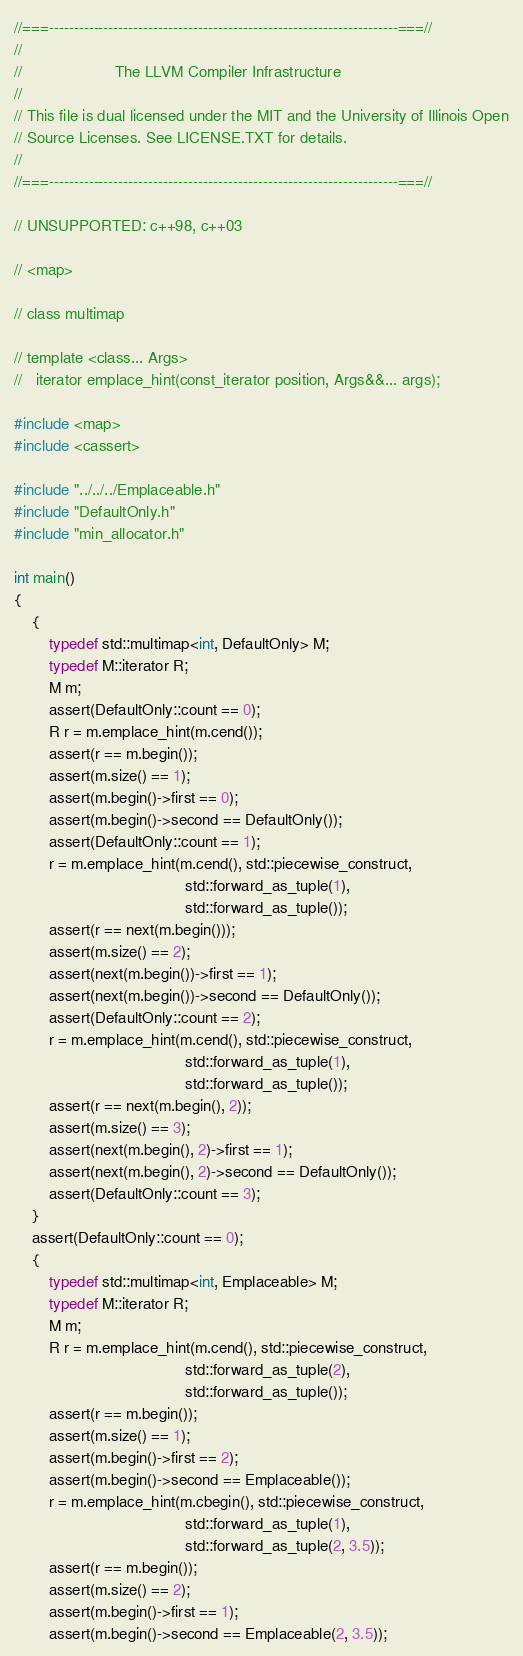Convert code to text. <code><loc_0><loc_0><loc_500><loc_500><_C++_>//===----------------------------------------------------------------------===//
//
//                     The LLVM Compiler Infrastructure
//
// This file is dual licensed under the MIT and the University of Illinois Open
// Source Licenses. See LICENSE.TXT for details.
//
//===----------------------------------------------------------------------===//

// UNSUPPORTED: c++98, c++03

// <map>

// class multimap

// template <class... Args>
//   iterator emplace_hint(const_iterator position, Args&&... args);

#include <map>
#include <cassert>

#include "../../../Emplaceable.h"
#include "DefaultOnly.h"
#include "min_allocator.h"

int main()
{
    {
        typedef std::multimap<int, DefaultOnly> M;
        typedef M::iterator R;
        M m;
        assert(DefaultOnly::count == 0);
        R r = m.emplace_hint(m.cend());
        assert(r == m.begin());
        assert(m.size() == 1);
        assert(m.begin()->first == 0);
        assert(m.begin()->second == DefaultOnly());
        assert(DefaultOnly::count == 1);
        r = m.emplace_hint(m.cend(), std::piecewise_construct,
                                       std::forward_as_tuple(1),
                                       std::forward_as_tuple());
        assert(r == next(m.begin()));
        assert(m.size() == 2);
        assert(next(m.begin())->first == 1);
        assert(next(m.begin())->second == DefaultOnly());
        assert(DefaultOnly::count == 2);
        r = m.emplace_hint(m.cend(), std::piecewise_construct,
                                       std::forward_as_tuple(1),
                                       std::forward_as_tuple());
        assert(r == next(m.begin(), 2));
        assert(m.size() == 3);
        assert(next(m.begin(), 2)->first == 1);
        assert(next(m.begin(), 2)->second == DefaultOnly());
        assert(DefaultOnly::count == 3);
    }
    assert(DefaultOnly::count == 0);
    {
        typedef std::multimap<int, Emplaceable> M;
        typedef M::iterator R;
        M m;
        R r = m.emplace_hint(m.cend(), std::piecewise_construct,
                                       std::forward_as_tuple(2),
                                       std::forward_as_tuple());
        assert(r == m.begin());
        assert(m.size() == 1);
        assert(m.begin()->first == 2);
        assert(m.begin()->second == Emplaceable());
        r = m.emplace_hint(m.cbegin(), std::piecewise_construct,
                                       std::forward_as_tuple(1),
                                       std::forward_as_tuple(2, 3.5));
        assert(r == m.begin());
        assert(m.size() == 2);
        assert(m.begin()->first == 1);
        assert(m.begin()->second == Emplaceable(2, 3.5));</code> 